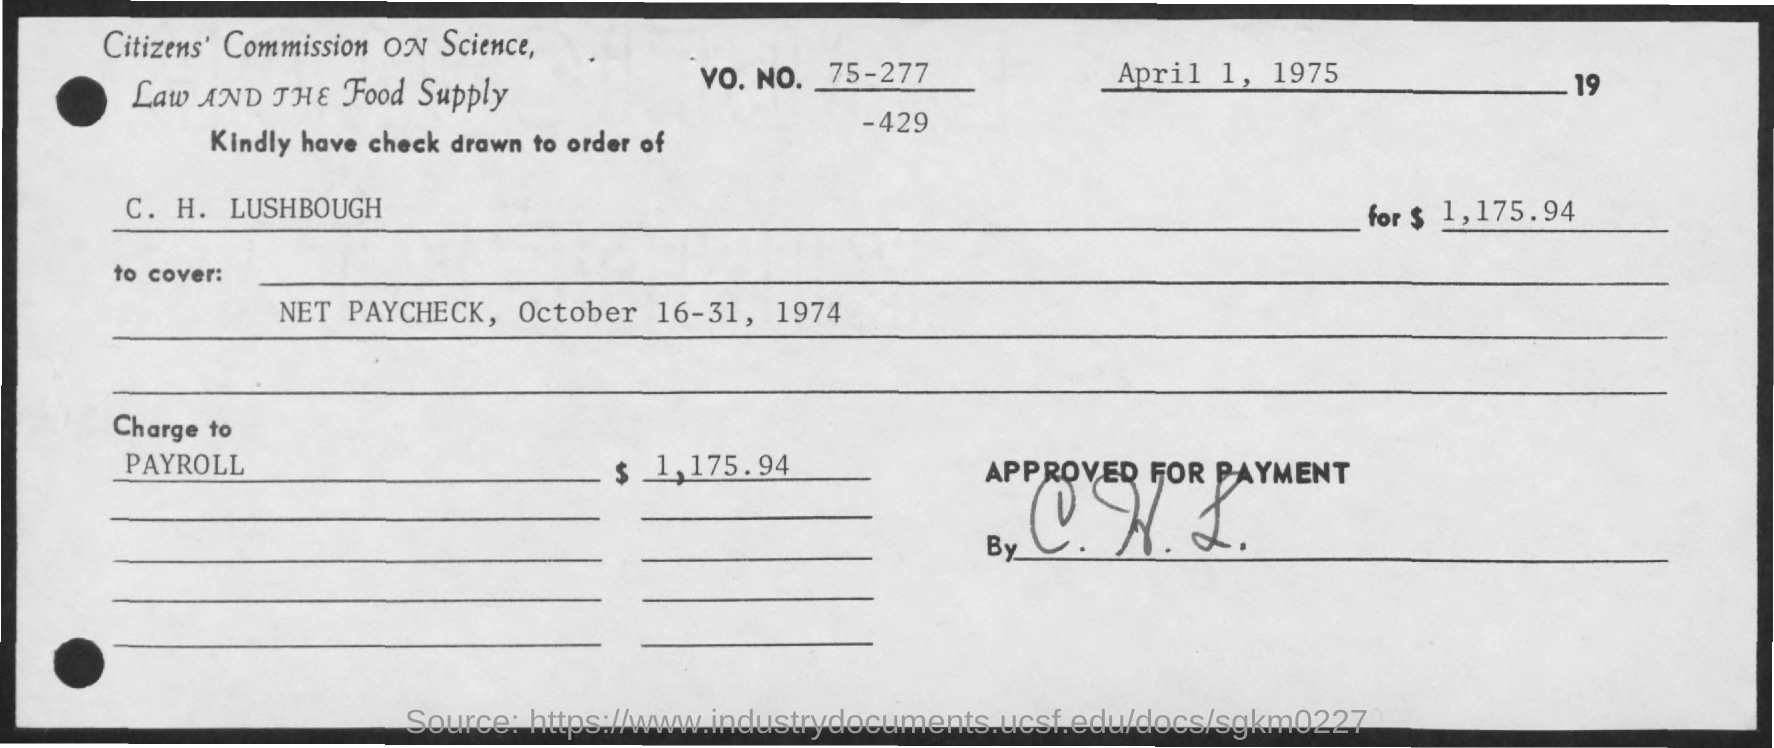Check is drawn to the order of?
Your answer should be very brief. C. h. lushbough. Check is drawn to cover?
Provide a short and direct response. Net Paycheck, October 16-31, 1974. What is the "charge to"?
Keep it short and to the point. Payroll. Whta is the VO. NO.?
Your response must be concise. 75-277. 